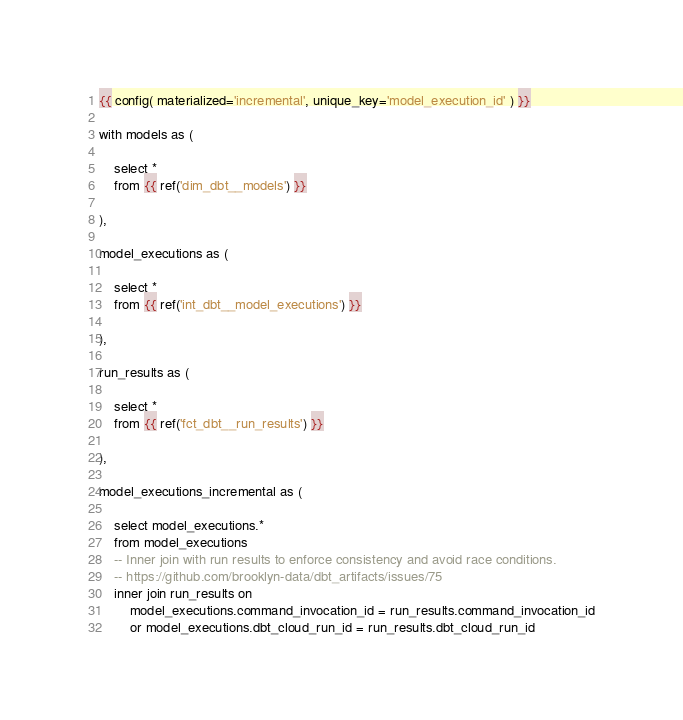Convert code to text. <code><loc_0><loc_0><loc_500><loc_500><_SQL_>{{ config( materialized='incremental', unique_key='model_execution_id' ) }}

with models as (

    select *
    from {{ ref('dim_dbt__models') }}

),

model_executions as (

    select *
    from {{ ref('int_dbt__model_executions') }}

),

run_results as (

    select *
    from {{ ref('fct_dbt__run_results') }}

),

model_executions_incremental as (

    select model_executions.*
    from model_executions
    -- Inner join with run results to enforce consistency and avoid race conditions.
    -- https://github.com/brooklyn-data/dbt_artifacts/issues/75
    inner join run_results on
        model_executions.command_invocation_id = run_results.command_invocation_id
        or model_executions.dbt_cloud_run_id = run_results.dbt_cloud_run_id
</code> 